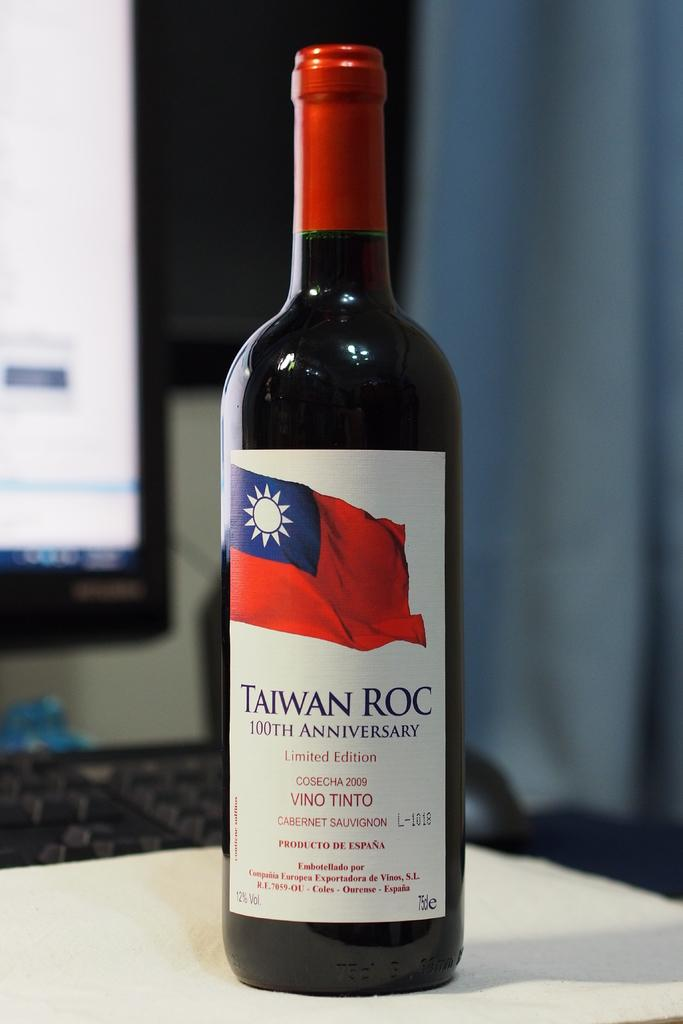Where was the image taken? The image was taken indoors. What can be seen in the background of the image? There is a wall in the background of the image. What is located at the bottom of the image? There is a table at the bottom of the image. What items are on the table in the image? There is a wine bottle, a keyboard, and a monitor on the table. What type of calculator is being used to approve the coach's decisions in the image? There is no calculator, approval, or coach present in the image. 